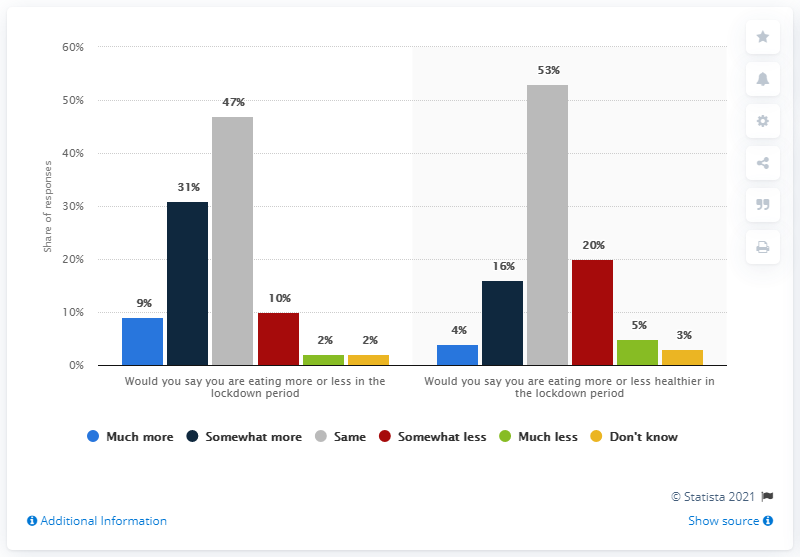Point out several critical features in this image. The number of people eating healthier during the lockdown period has significantly increased, with a reported 4% increase in healthier eating behaviors among individuals. The average score for students in both categories is 50. 